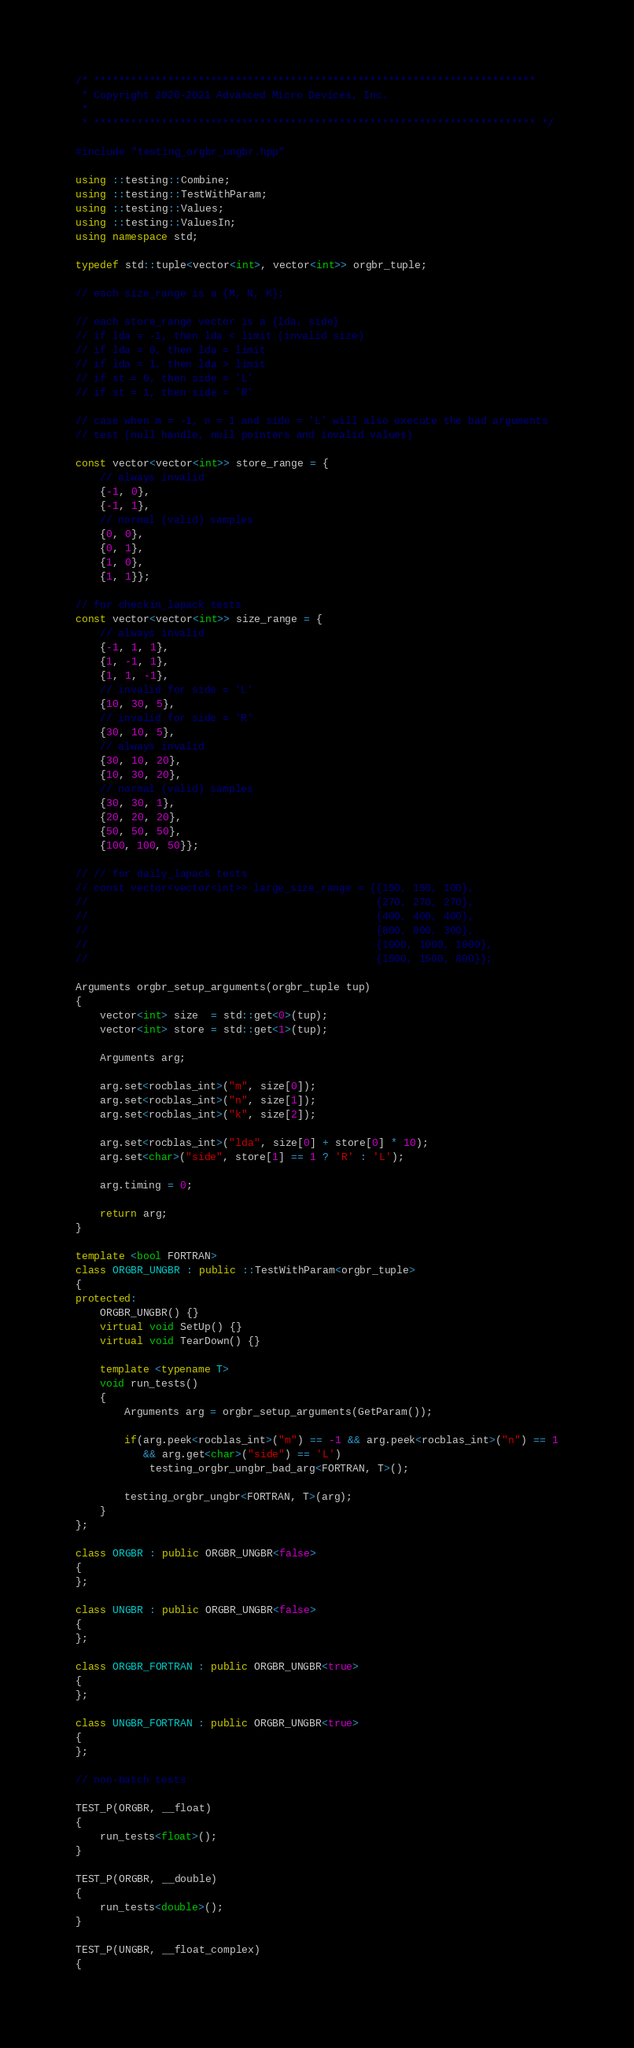<code> <loc_0><loc_0><loc_500><loc_500><_C++_>/* ************************************************************************
 * Copyright 2020-2021 Advanced Micro Devices, Inc.
 *
 * ************************************************************************ */

#include "testing_orgbr_ungbr.hpp"

using ::testing::Combine;
using ::testing::TestWithParam;
using ::testing::Values;
using ::testing::ValuesIn;
using namespace std;

typedef std::tuple<vector<int>, vector<int>> orgbr_tuple;

// each size_range is a {M, N, K};

// each store_range vector is a {lda, side}
// if lda = -1, then lda < limit (invalid size)
// if lda = 0, then lda = limit
// if lda = 1, then lda > limit
// if st = 0, then side = 'L'
// if st = 1, then side = 'R'

// case when m = -1, n = 1 and side = 'L' will also execute the bad arguments
// test (null handle, null pointers and invalid values)

const vector<vector<int>> store_range = {
    // always invalid
    {-1, 0},
    {-1, 1},
    // normal (valid) samples
    {0, 0},
    {0, 1},
    {1, 0},
    {1, 1}};

// for checkin_lapack tests
const vector<vector<int>> size_range = {
    // always invalid
    {-1, 1, 1},
    {1, -1, 1},
    {1, 1, -1},
    // invalid for side = 'L'
    {10, 30, 5},
    // invalid for side = 'R'
    {30, 10, 5},
    // always invalid
    {30, 10, 20},
    {10, 30, 20},
    // normal (valid) samples
    {30, 30, 1},
    {20, 20, 20},
    {50, 50, 50},
    {100, 100, 50}};

// // for daily_lapack tests
// const vector<vector<int>> large_size_range = {{150, 150, 100},
//                                               {270, 270, 270},
//                                               {400, 400, 400},
//                                               {800, 800, 300},
//                                               {1000, 1000, 1000},
//                                               {1500, 1500, 800}};

Arguments orgbr_setup_arguments(orgbr_tuple tup)
{
    vector<int> size  = std::get<0>(tup);
    vector<int> store = std::get<1>(tup);

    Arguments arg;

    arg.set<rocblas_int>("m", size[0]);
    arg.set<rocblas_int>("n", size[1]);
    arg.set<rocblas_int>("k", size[2]);

    arg.set<rocblas_int>("lda", size[0] + store[0] * 10);
    arg.set<char>("side", store[1] == 1 ? 'R' : 'L');

    arg.timing = 0;

    return arg;
}

template <bool FORTRAN>
class ORGBR_UNGBR : public ::TestWithParam<orgbr_tuple>
{
protected:
    ORGBR_UNGBR() {}
    virtual void SetUp() {}
    virtual void TearDown() {}

    template <typename T>
    void run_tests()
    {
        Arguments arg = orgbr_setup_arguments(GetParam());

        if(arg.peek<rocblas_int>("m") == -1 && arg.peek<rocblas_int>("n") == 1
           && arg.get<char>("side") == 'L')
            testing_orgbr_ungbr_bad_arg<FORTRAN, T>();

        testing_orgbr_ungbr<FORTRAN, T>(arg);
    }
};

class ORGBR : public ORGBR_UNGBR<false>
{
};

class UNGBR : public ORGBR_UNGBR<false>
{
};

class ORGBR_FORTRAN : public ORGBR_UNGBR<true>
{
};

class UNGBR_FORTRAN : public ORGBR_UNGBR<true>
{
};

// non-batch tests

TEST_P(ORGBR, __float)
{
    run_tests<float>();
}

TEST_P(ORGBR, __double)
{
    run_tests<double>();
}

TEST_P(UNGBR, __float_complex)
{</code> 